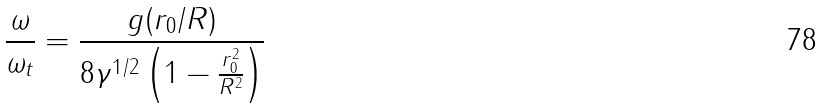Convert formula to latex. <formula><loc_0><loc_0><loc_500><loc_500>\frac { \omega } { \omega _ { t } } = \frac { g ( r _ { 0 } / R ) } { 8 \gamma ^ { 1 / 2 } \left ( 1 - \frac { r _ { 0 } ^ { 2 } } { R ^ { 2 } } \right ) }</formula> 